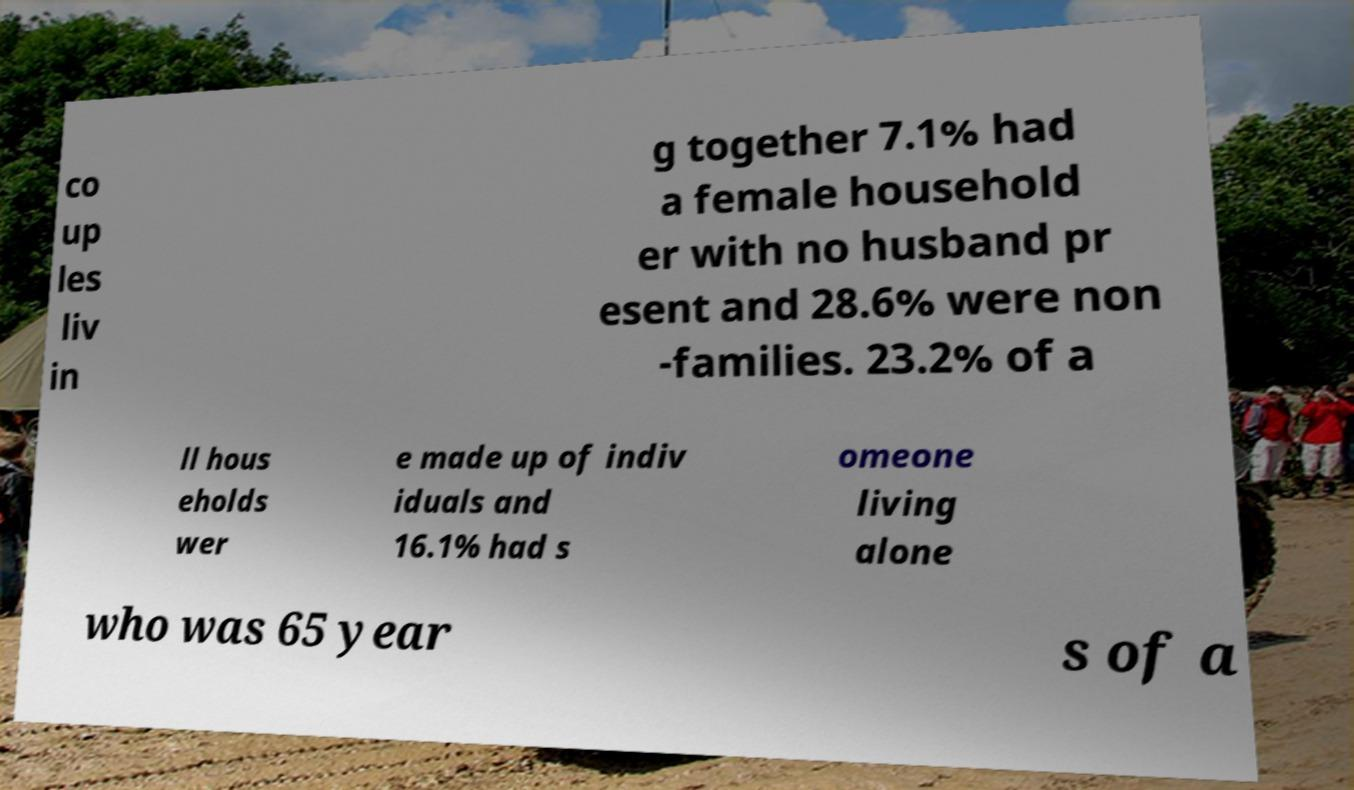What messages or text are displayed in this image? I need them in a readable, typed format. co up les liv in g together 7.1% had a female household er with no husband pr esent and 28.6% were non -families. 23.2% of a ll hous eholds wer e made up of indiv iduals and 16.1% had s omeone living alone who was 65 year s of a 